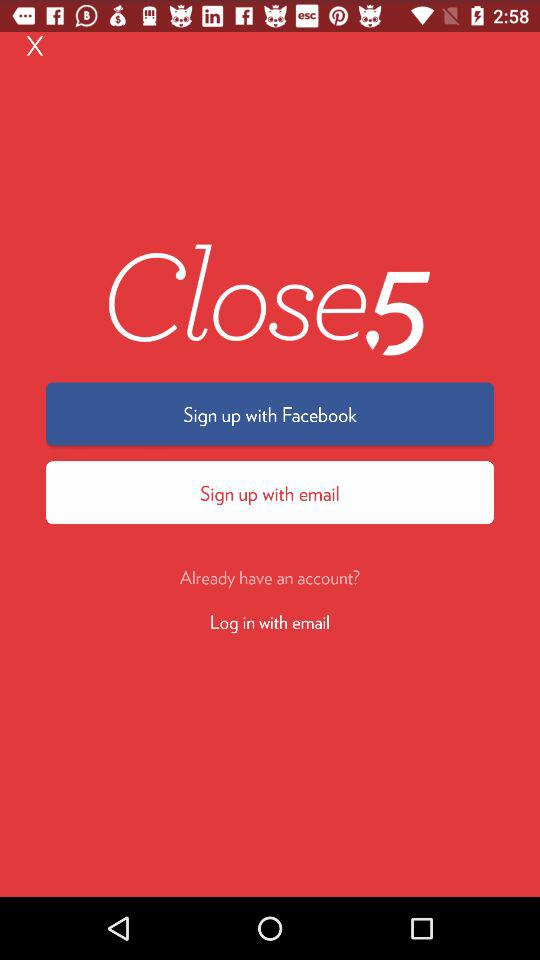What are the different sign up option? The different sign up options are "Facebook" and "email". 